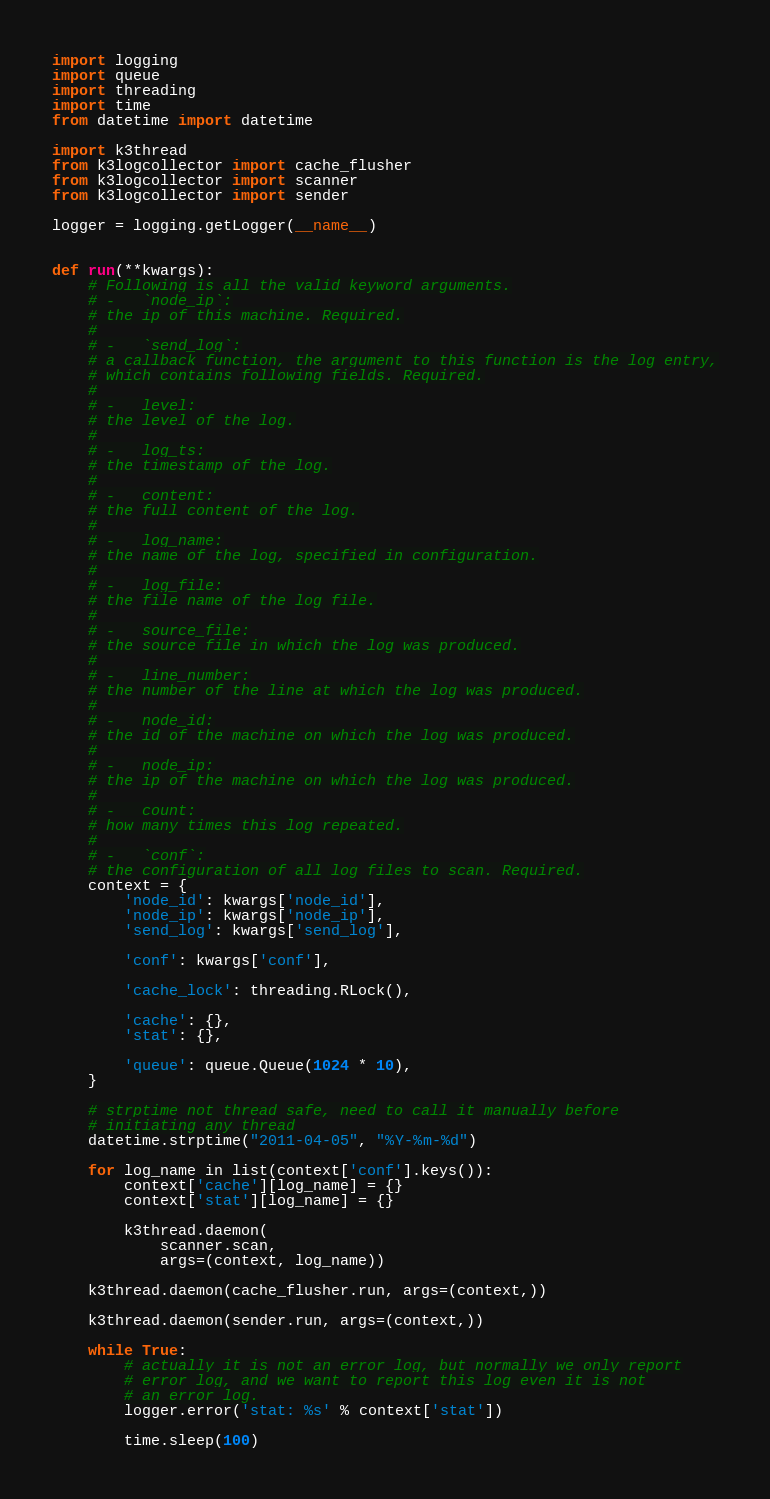Convert code to text. <code><loc_0><loc_0><loc_500><loc_500><_Python_>import logging
import queue
import threading
import time
from datetime import datetime

import k3thread
from k3logcollector import cache_flusher
from k3logcollector import scanner
from k3logcollector import sender

logger = logging.getLogger(__name__)


def run(**kwargs):
    # Following is all the valid keyword arguments.
    # -   `node_ip`:
    # the ip of this machine. Required.
    #
    # -   `send_log`:
    # a callback function, the argument to this function is the log entry,
    # which contains following fields. Required.
    #
    # -   level:
    # the level of the log.
    #
    # -   log_ts:
    # the timestamp of the log.
    #
    # -   content:
    # the full content of the log.
    #
    # -   log_name:
    # the name of the log, specified in configuration.
    #
    # -   log_file:
    # the file name of the log file.
    #
    # -   source_file:
    # the source file in which the log was produced.
    #
    # -   line_number:
    # the number of the line at which the log was produced.
    #
    # -   node_id:
    # the id of the machine on which the log was produced.
    #
    # -   node_ip:
    # the ip of the machine on which the log was produced.
    #
    # -   count:
    # how many times this log repeated.
    #
    # -   `conf`:
    # the configuration of all log files to scan. Required.
    context = {
        'node_id': kwargs['node_id'],
        'node_ip': kwargs['node_ip'],
        'send_log': kwargs['send_log'],

        'conf': kwargs['conf'],

        'cache_lock': threading.RLock(),

        'cache': {},
        'stat': {},

        'queue': queue.Queue(1024 * 10),
    }

    # strptime not thread safe, need to call it manually before
    # initiating any thread
    datetime.strptime("2011-04-05", "%Y-%m-%d")

    for log_name in list(context['conf'].keys()):
        context['cache'][log_name] = {}
        context['stat'][log_name] = {}

        k3thread.daemon(
            scanner.scan,
            args=(context, log_name))

    k3thread.daemon(cache_flusher.run, args=(context,))

    k3thread.daemon(sender.run, args=(context,))

    while True:
        # actually it is not an error log, but normally we only report
        # error log, and we want to report this log even it is not
        # an error log.
        logger.error('stat: %s' % context['stat'])

        time.sleep(100)
</code> 